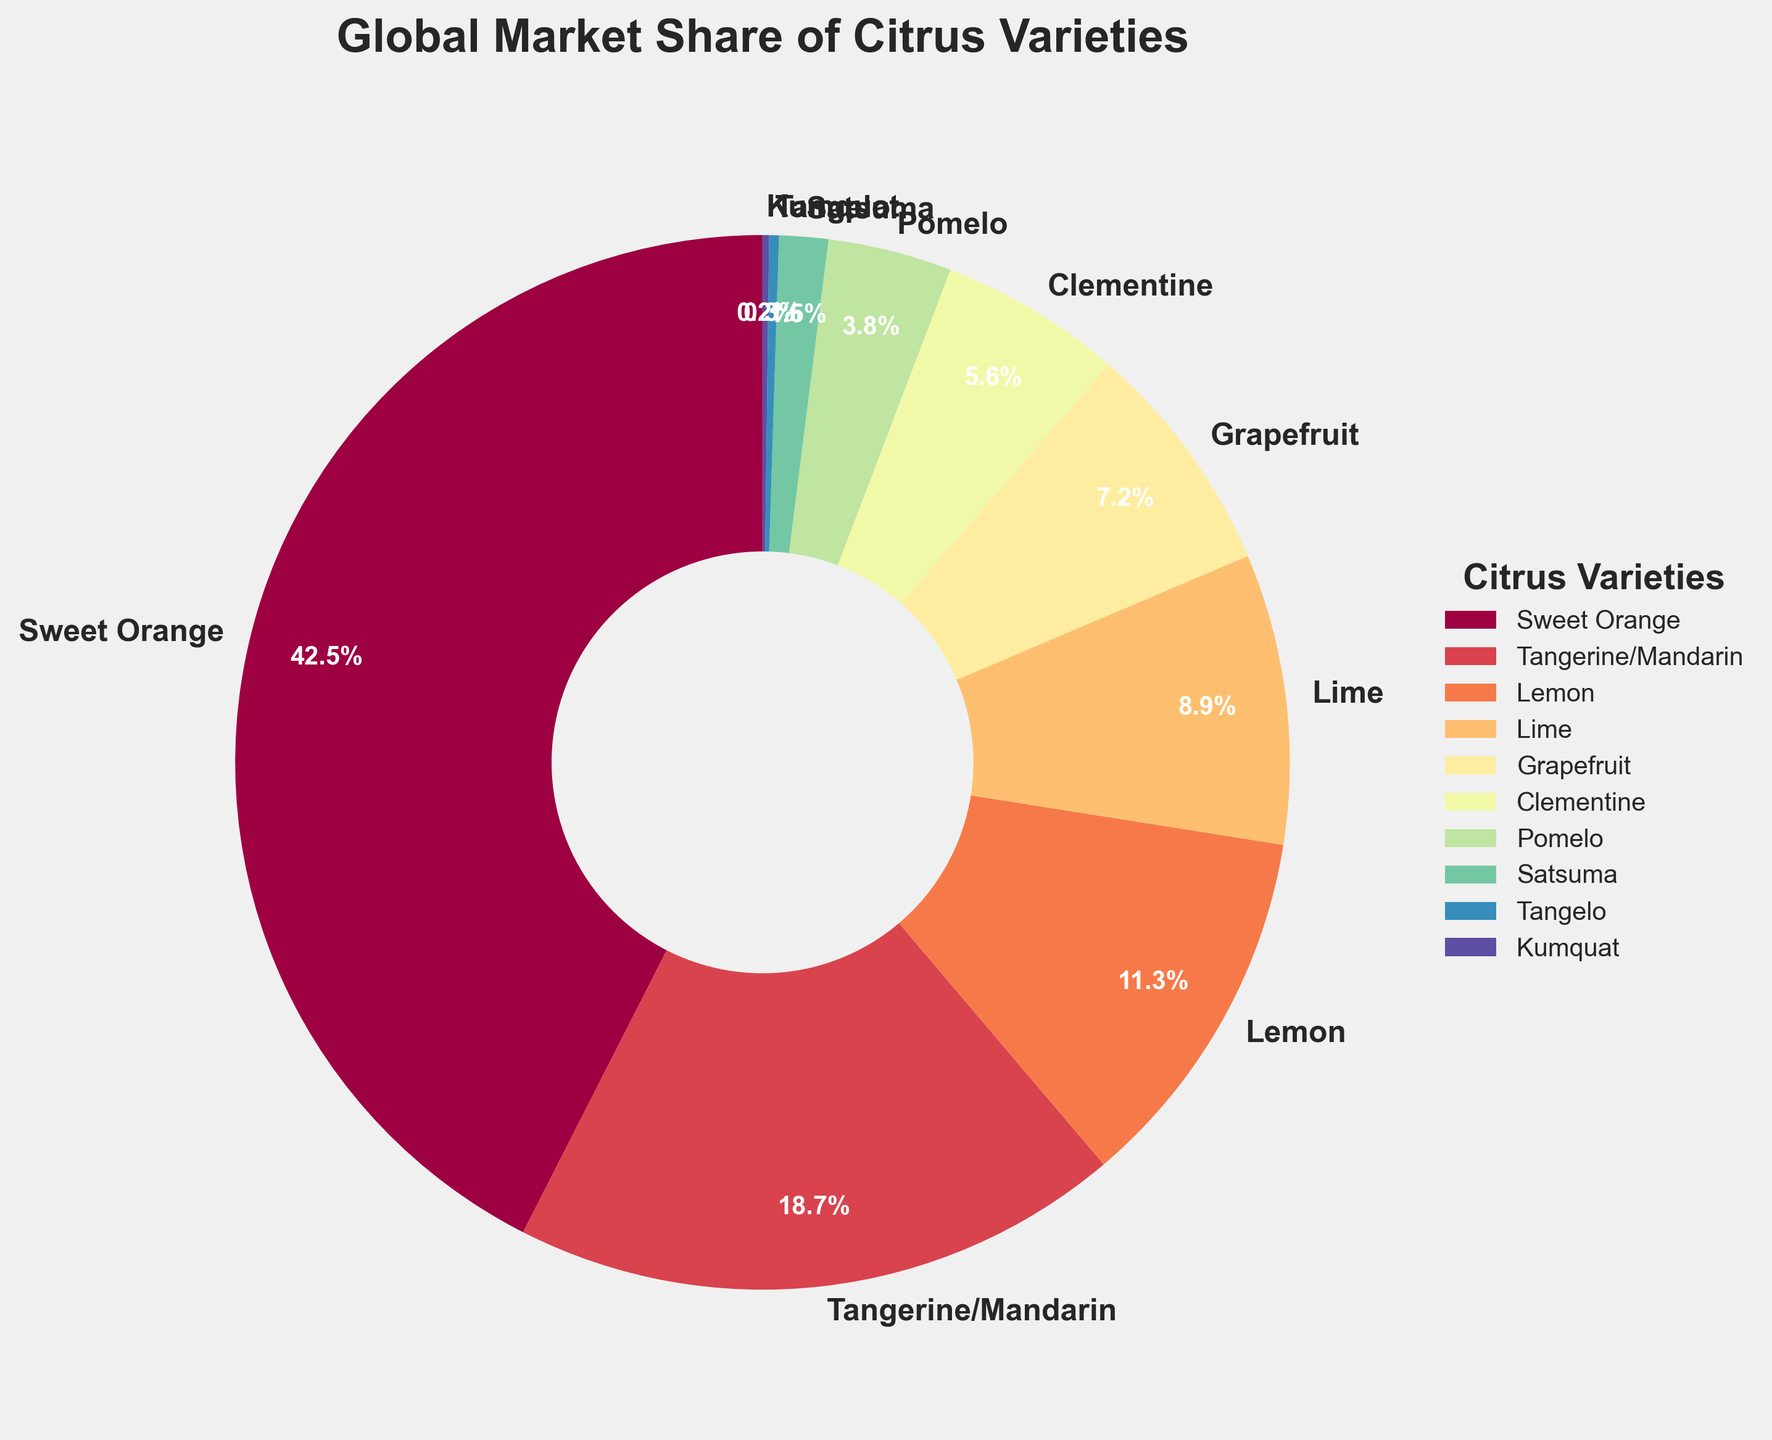What's the most common citrus variety by market share? The largest wedge in the pie chart indicates the most common citrus variety. The 'Sweet Orange' variety occupies the biggest section, with 42.5% of the market share.
Answer: Sweet Orange Which citrus variety holds the smallest market share? The smallest wedge represents the citrus variety with the lowest market share. 'Kumquat' occupies the least portion with just 0.2% of the market share.
Answer: Kumquat What is the combined market share of lemons and limes? To find the combined market share, add the percentages of lemons and limes. Lemon has 11.3% and Lime has 8.9%, so their combined share is 11.3% + 8.9% = 20.2%.
Answer: 20.2% How much larger is the market share of Sweet Orange compared to Tangerine/Mandarin? The difference can be calculated by subtracting the market share of Tangerine/Mandarin from Sweet Orange. Sweet Orange has 42.5% and Tangerine/Mandarin has 18.7%, so the difference is 42.5% - 18.7% = 23.8%.
Answer: 23.8% Are the combined market shares of Pomelo, Satsuma, Tangelo, and Kumquat greater or less than that of Grapefruit? First, sum the market shares of Pomelo, Satsuma, Tangelo, and Kumquat: 3.8% + 1.5% + 0.3% + 0.2% = 5.8%. Compare this to the market share of Grapefruit, which is 7.2%. Since 5.8% < 7.2%, the combined market shares are less than that of Grapefruit.
Answer: Less Which variety has a wedge with a prominent bright color, typically found in a pie chart using the Spectral color map? The Spectral color map typically scales from dark red to bright yellow. The bright yellow color is often prominent. In the visual context of the pie chart, the wedge for 'Lime' often stands out with a bright color.
Answer: Lime What percentage of the market do the bottom three varieties combined account for? Sum the market shares of the bottom three varieties: Satsuma (1.5%), Tangelo (0.3%), and Kumquat (0.2%). The total is 1.5% + 0.3% + 0.2% = 2%.
Answer: 2% How does the market share of Grapefruit compare to that of Clementine? The market share of Grapefruit (7.2%) is greater than that of Clementine (5.6%). The comparison shows Grapefruit is more dominant by 1.6%.
Answer: Greater What is the average market share of the top three citrus varieties? Identify the top three varieties by market share: Sweet Orange (42.5%), Tangerine/Mandarin (18.7%), and Lemon (11.3%). Calculate the average: (42.5% + 18.7% + 11.3%) / 3 = 24.166%.
Answer: 24.2% 